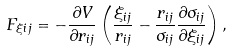<formula> <loc_0><loc_0><loc_500><loc_500>F _ { \xi i j } = - \frac { \partial V } { \partial r _ { i j } } \left ( \frac { \xi _ { i j } } { r _ { i j } } - \frac { r _ { i j } } { \sigma _ { i j } } \frac { \partial \sigma _ { i j } } { \partial \xi _ { i j } } \right ) ,</formula> 